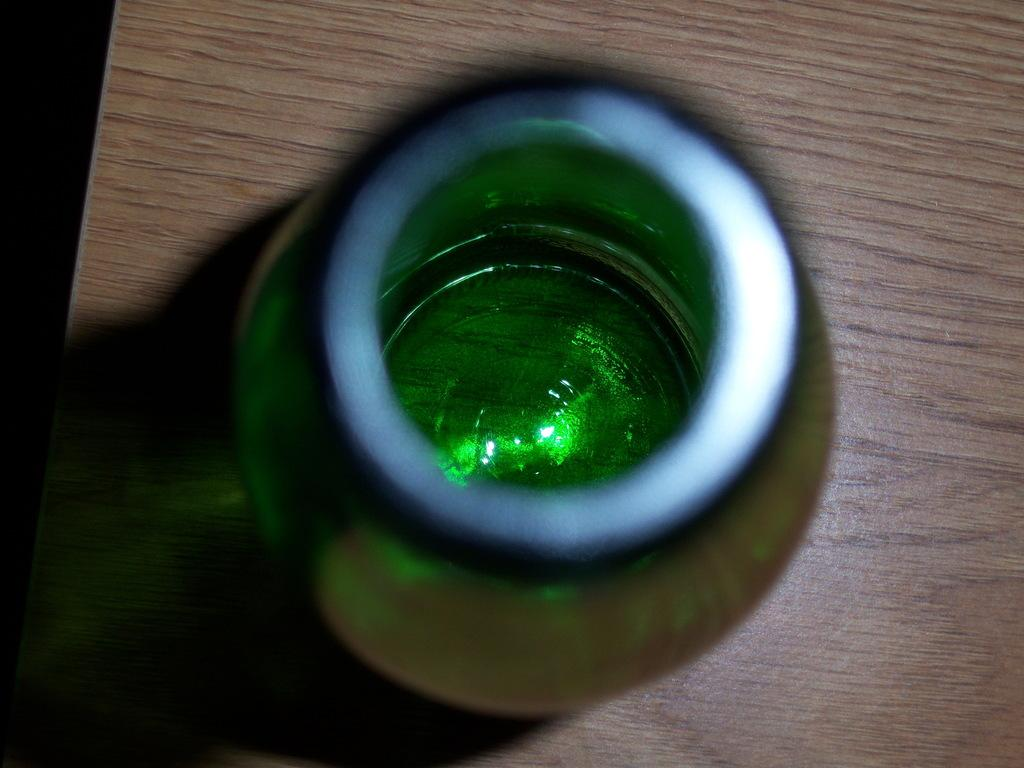What type of furniture is present in the image? There is a table in the image. What is the color of the table? The table is brown in color. What object is placed on the table? There is a bottle on the table. What is the color of the bottle? The bottle is green in color. What type of building is visible in the image? There is no building visible in the image; it only features a table and a bottle. How many homes are present in the image? There are no homes present in the image. 